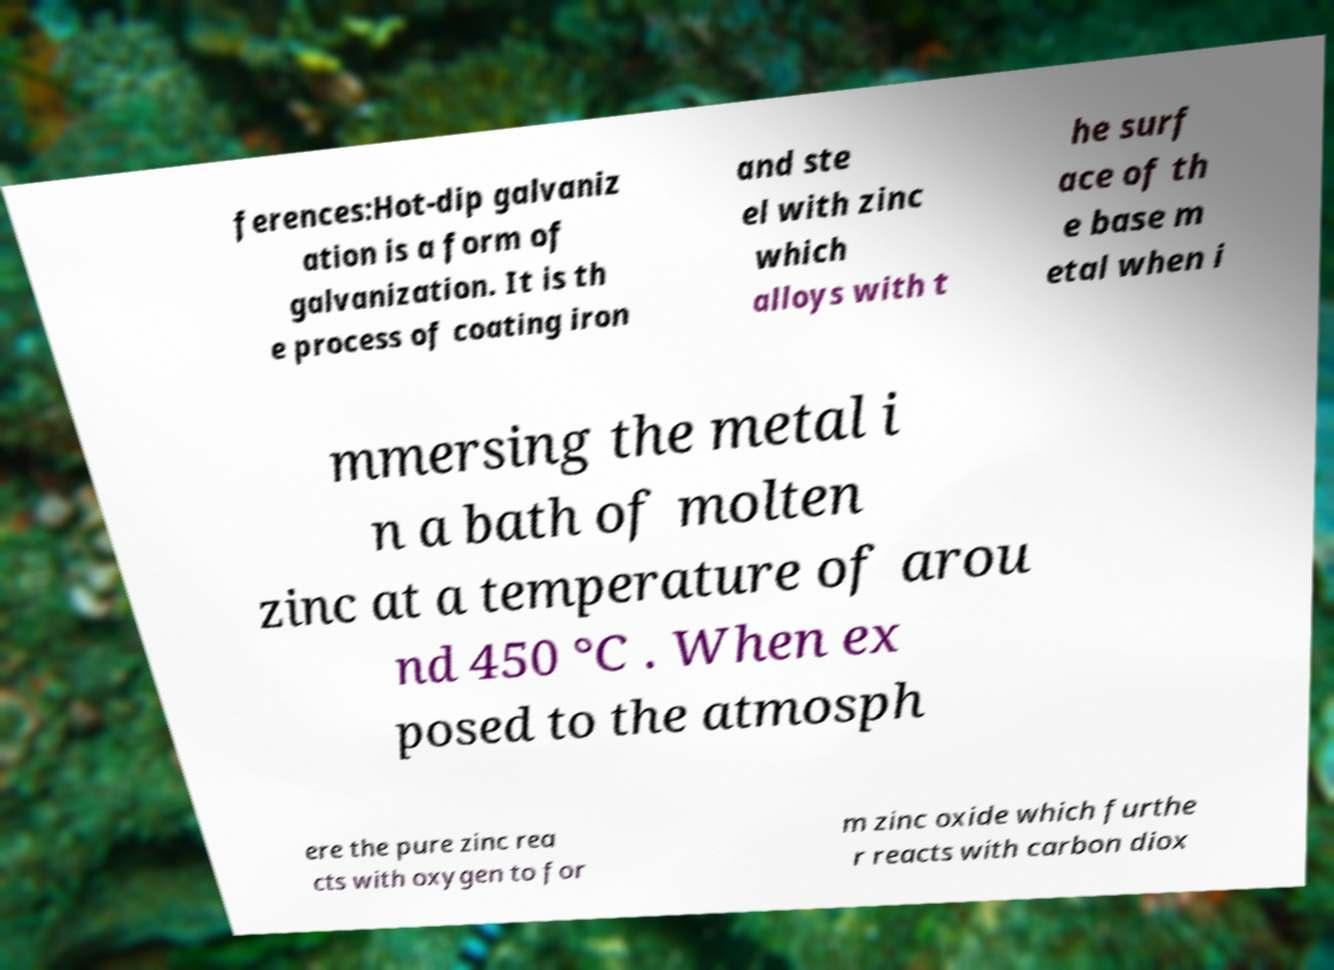Please read and relay the text visible in this image. What does it say? ferences:Hot-dip galvaniz ation is a form of galvanization. It is th e process of coating iron and ste el with zinc which alloys with t he surf ace of th e base m etal when i mmersing the metal i n a bath of molten zinc at a temperature of arou nd 450 °C . When ex posed to the atmosph ere the pure zinc rea cts with oxygen to for m zinc oxide which furthe r reacts with carbon diox 